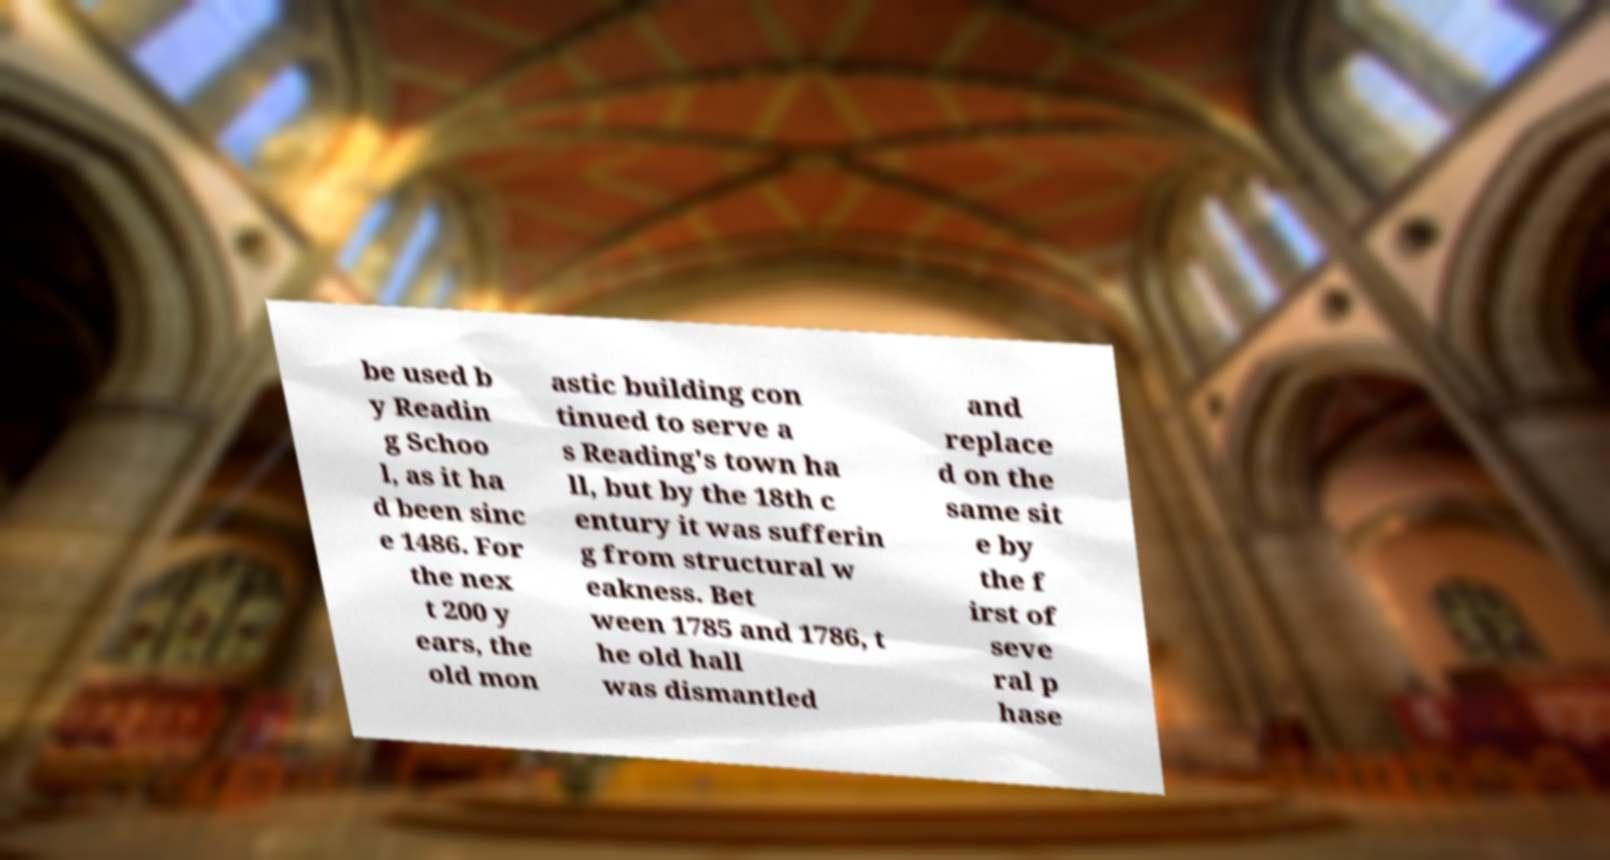Could you assist in decoding the text presented in this image and type it out clearly? be used b y Readin g Schoo l, as it ha d been sinc e 1486. For the nex t 200 y ears, the old mon astic building con tinued to serve a s Reading's town ha ll, but by the 18th c entury it was sufferin g from structural w eakness. Bet ween 1785 and 1786, t he old hall was dismantled and replace d on the same sit e by the f irst of seve ral p hase 